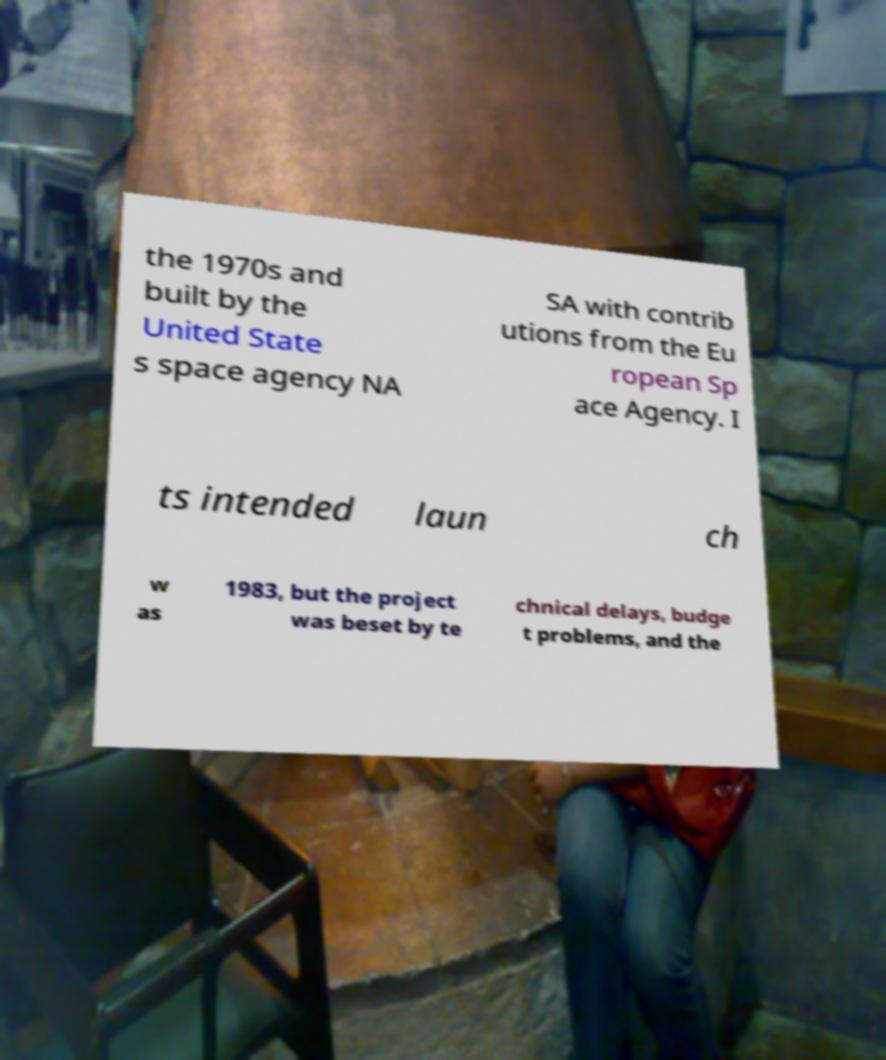Could you extract and type out the text from this image? the 1970s and built by the United State s space agency NA SA with contrib utions from the Eu ropean Sp ace Agency. I ts intended laun ch w as 1983, but the project was beset by te chnical delays, budge t problems, and the 